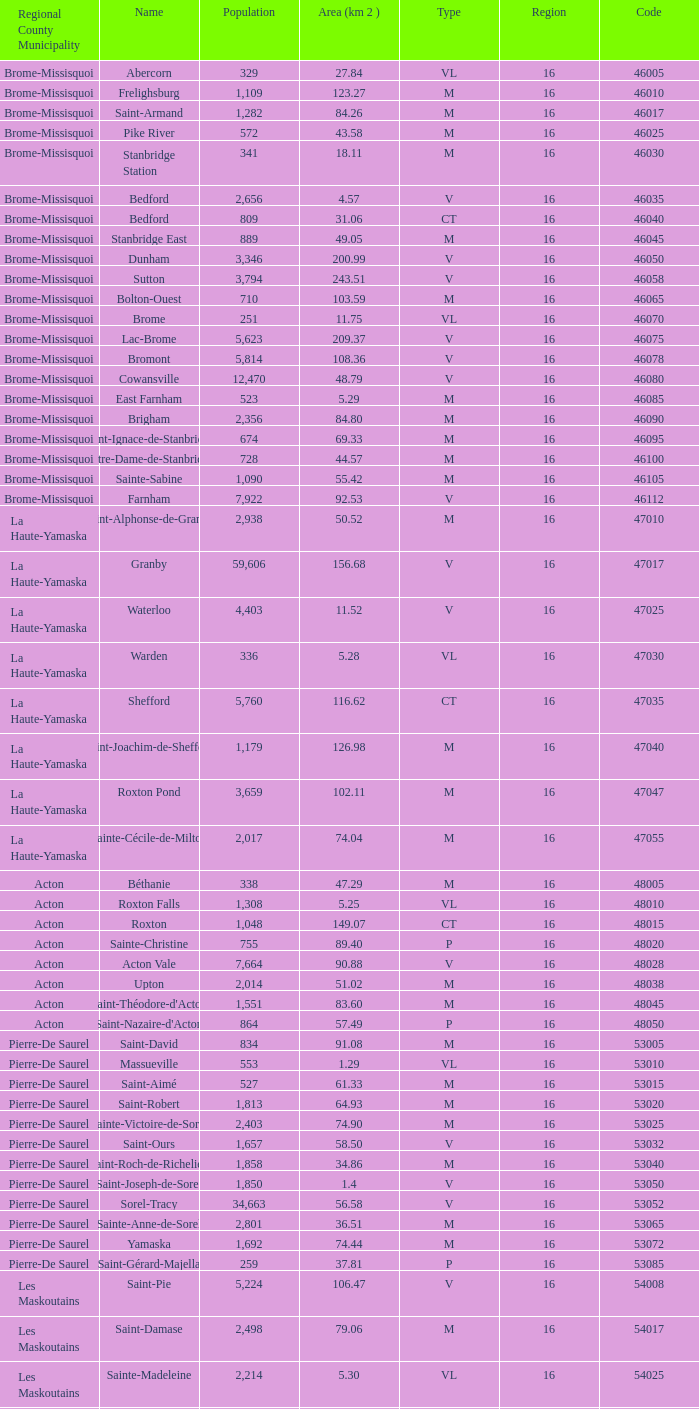What is the code for a Le Haut-Saint-Laurent municipality that has 16 or more regions? None. 